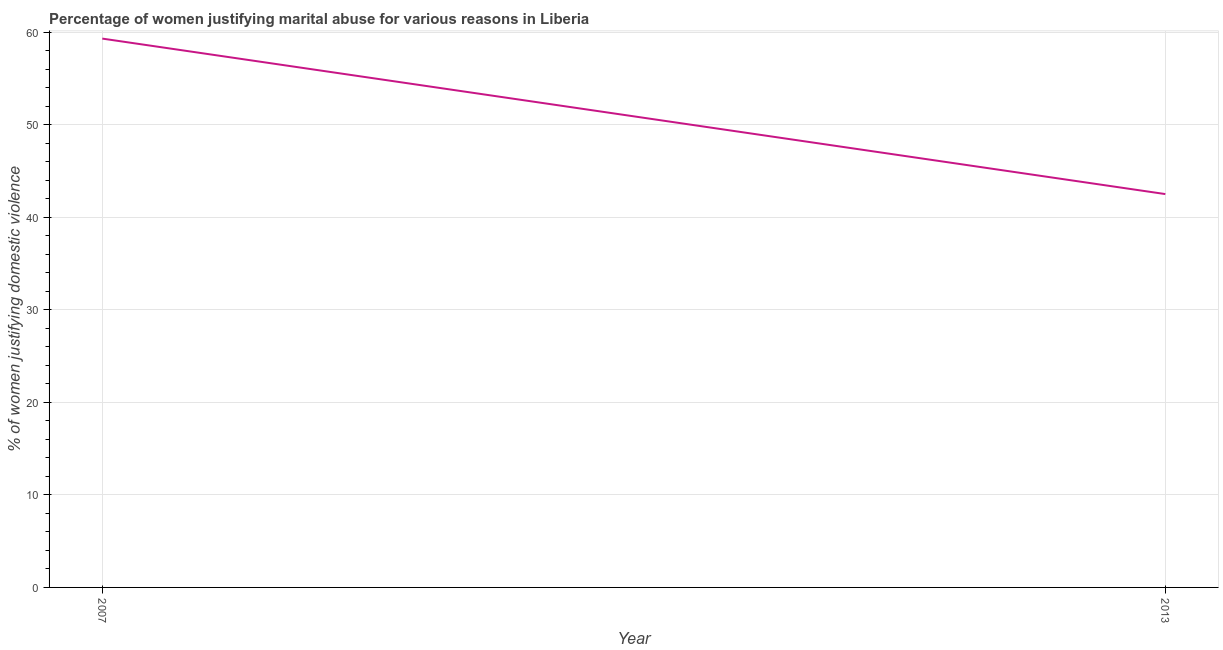What is the percentage of women justifying marital abuse in 2007?
Provide a succinct answer. 59.3. Across all years, what is the maximum percentage of women justifying marital abuse?
Your answer should be very brief. 59.3. Across all years, what is the minimum percentage of women justifying marital abuse?
Offer a terse response. 42.5. In which year was the percentage of women justifying marital abuse maximum?
Offer a very short reply. 2007. In which year was the percentage of women justifying marital abuse minimum?
Ensure brevity in your answer.  2013. What is the sum of the percentage of women justifying marital abuse?
Offer a very short reply. 101.8. What is the difference between the percentage of women justifying marital abuse in 2007 and 2013?
Give a very brief answer. 16.8. What is the average percentage of women justifying marital abuse per year?
Your response must be concise. 50.9. What is the median percentage of women justifying marital abuse?
Make the answer very short. 50.9. In how many years, is the percentage of women justifying marital abuse greater than 10 %?
Make the answer very short. 2. What is the ratio of the percentage of women justifying marital abuse in 2007 to that in 2013?
Keep it short and to the point. 1.4. Does the percentage of women justifying marital abuse monotonically increase over the years?
Provide a succinct answer. No. What is the difference between two consecutive major ticks on the Y-axis?
Keep it short and to the point. 10. Does the graph contain any zero values?
Your answer should be compact. No. Does the graph contain grids?
Make the answer very short. Yes. What is the title of the graph?
Keep it short and to the point. Percentage of women justifying marital abuse for various reasons in Liberia. What is the label or title of the X-axis?
Keep it short and to the point. Year. What is the label or title of the Y-axis?
Offer a very short reply. % of women justifying domestic violence. What is the % of women justifying domestic violence of 2007?
Ensure brevity in your answer.  59.3. What is the % of women justifying domestic violence of 2013?
Your response must be concise. 42.5. What is the difference between the % of women justifying domestic violence in 2007 and 2013?
Your answer should be compact. 16.8. What is the ratio of the % of women justifying domestic violence in 2007 to that in 2013?
Make the answer very short. 1.4. 